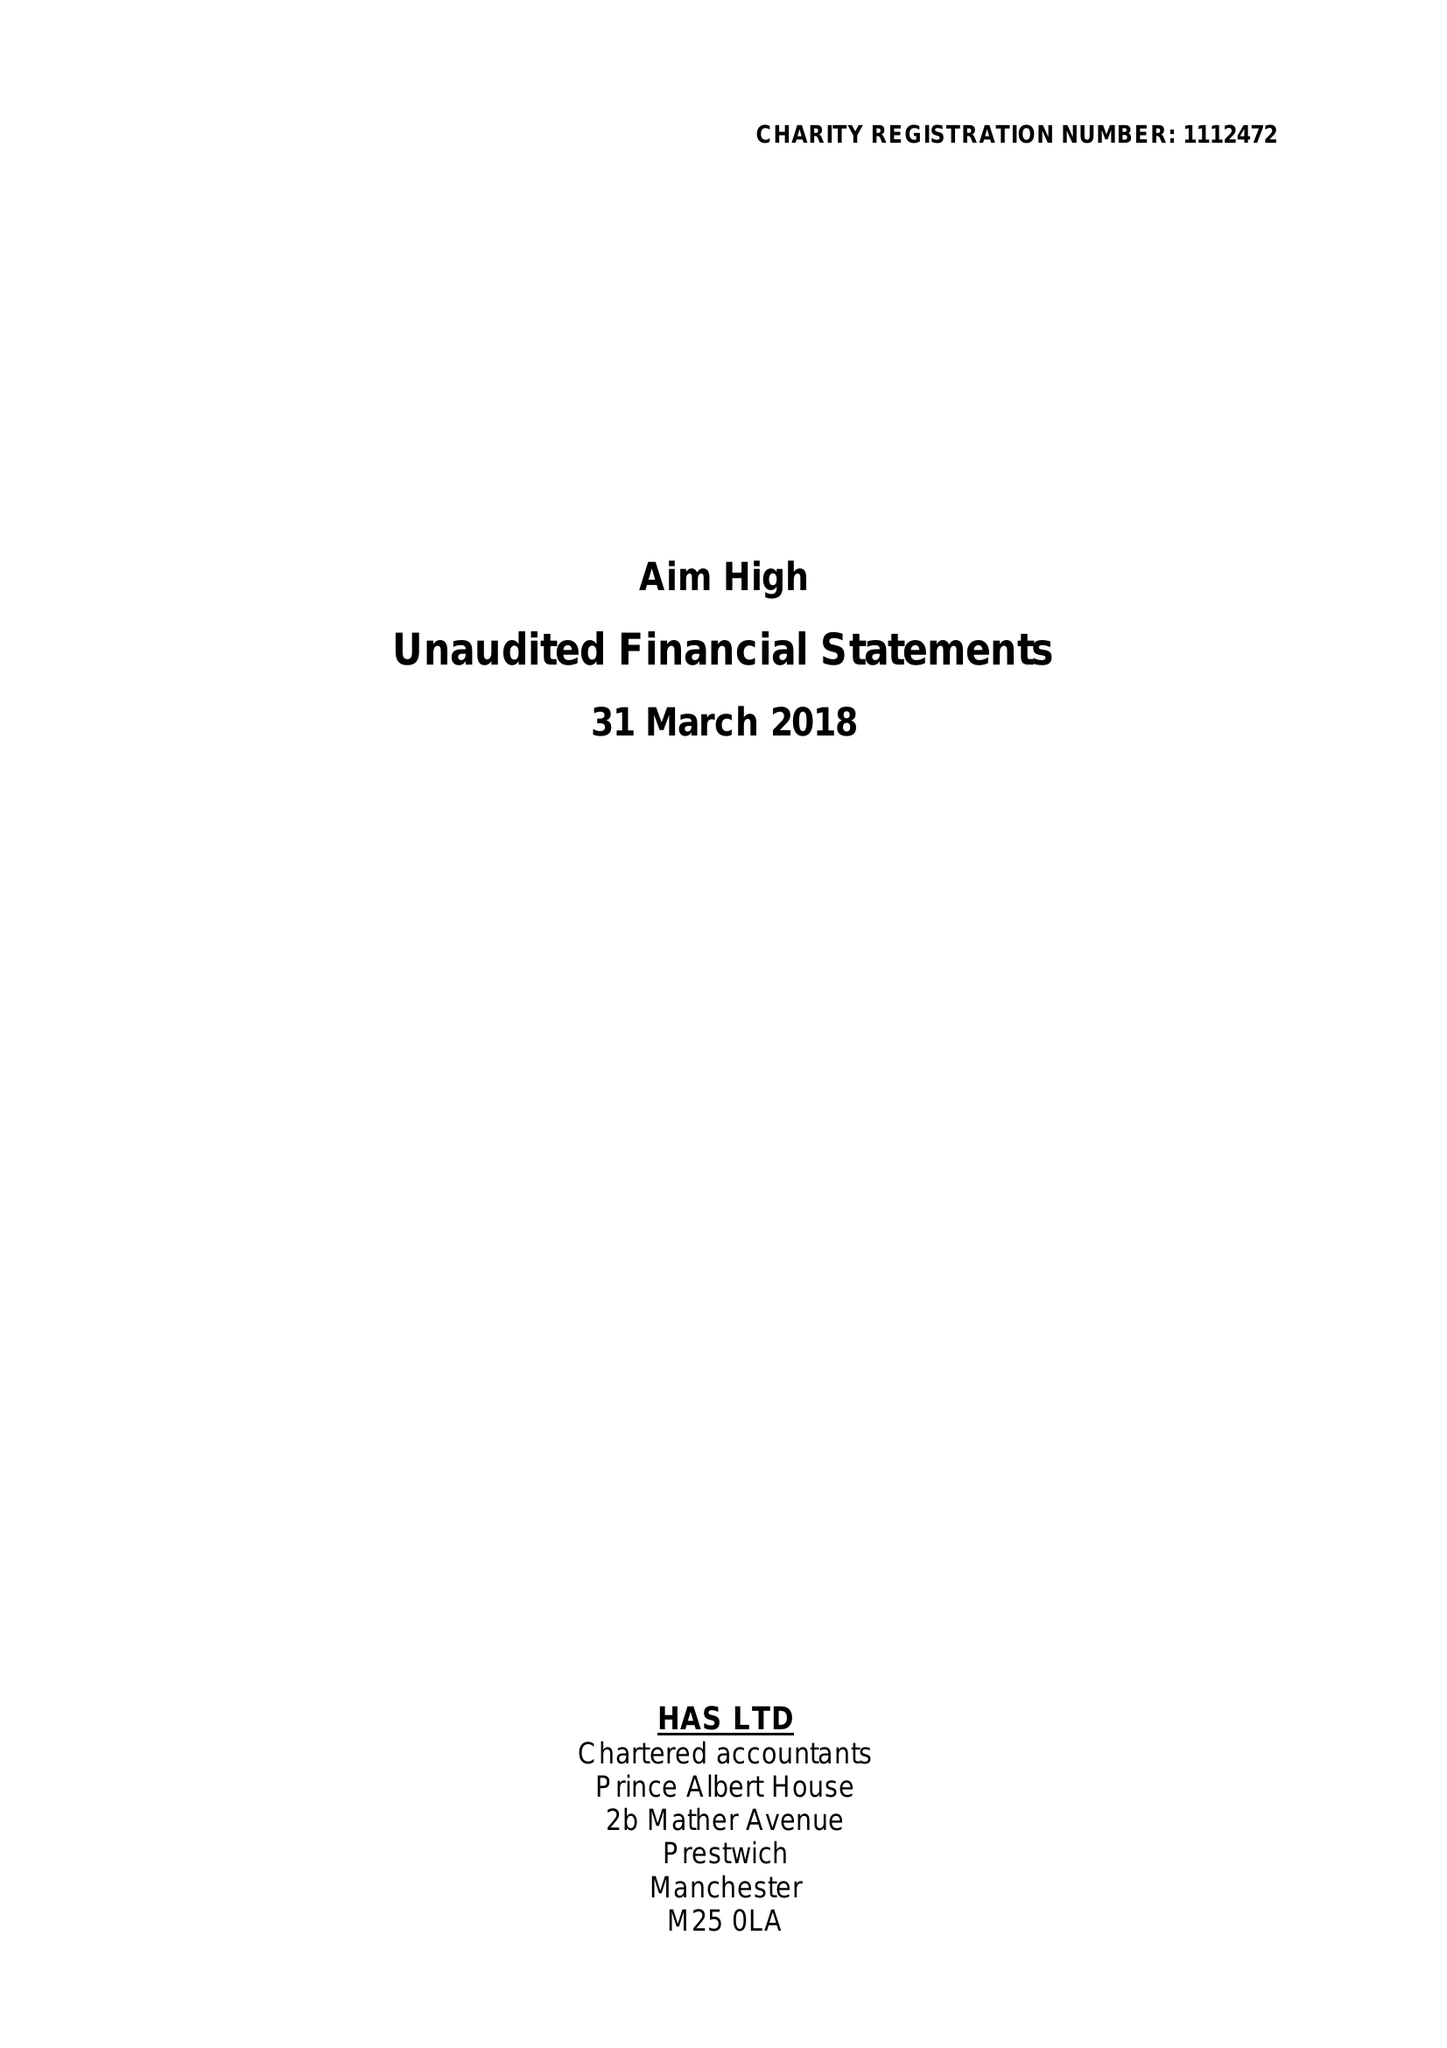What is the value for the charity_number?
Answer the question using a single word or phrase. 1112472 